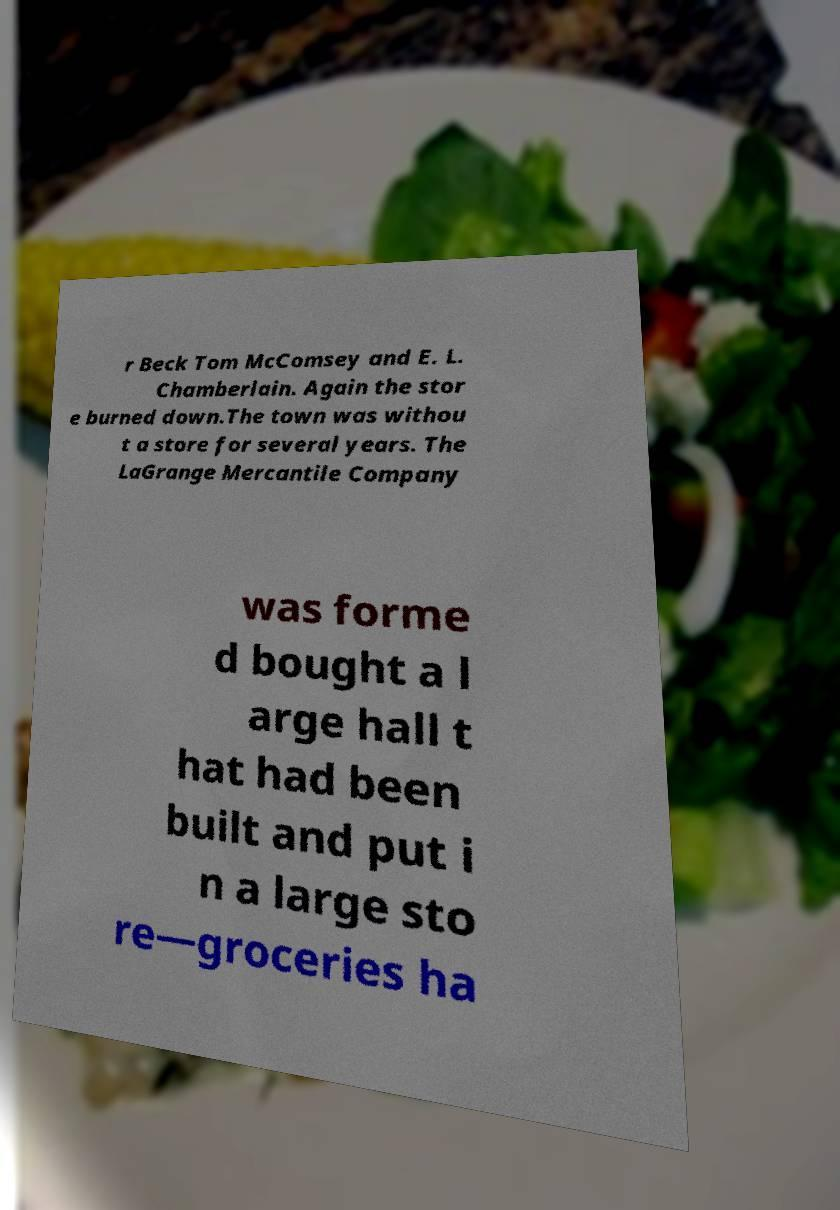Please read and relay the text visible in this image. What does it say? r Beck Tom McComsey and E. L. Chamberlain. Again the stor e burned down.The town was withou t a store for several years. The LaGrange Mercantile Company was forme d bought a l arge hall t hat had been built and put i n a large sto re—groceries ha 